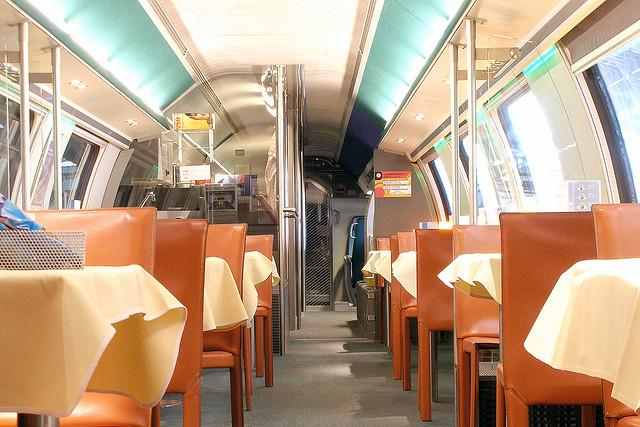Where is this dining room located in all likelihood? Please explain your reasoning. train. Some long trains have dining carts and the shape of the room looks like the interior of a train. 